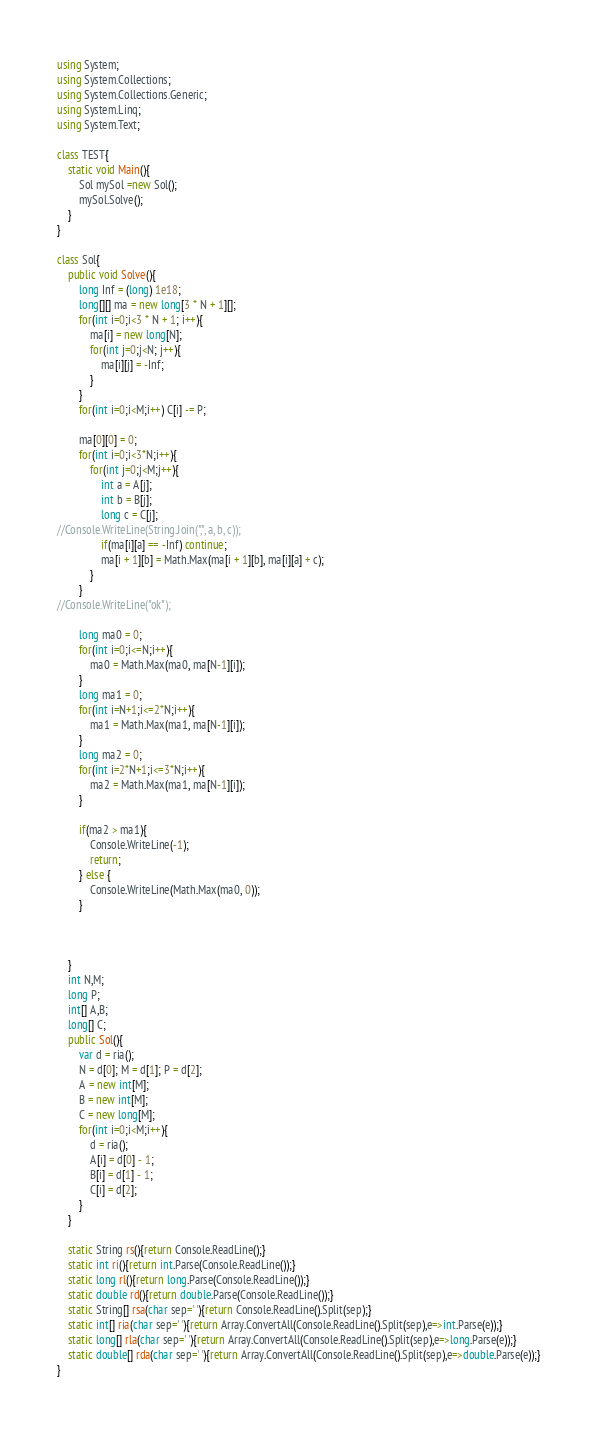Convert code to text. <code><loc_0><loc_0><loc_500><loc_500><_C#_>using System;
using System.Collections;
using System.Collections.Generic;
using System.Linq;
using System.Text;

class TEST{
	static void Main(){
		Sol mySol =new Sol();
		mySol.Solve();
	}
}

class Sol{
	public void Solve(){
		long Inf = (long) 1e18;
		long[][] ma = new long[3 * N + 1][];
		for(int i=0;i<3 * N + 1; i++){
			ma[i] = new long[N];
			for(int j=0;j<N; j++){
				ma[i][j] = -Inf;
			}
		}
		for(int i=0;i<M;i++) C[i] -= P;
		
		ma[0][0] = 0;
		for(int i=0;i<3*N;i++){
			for(int j=0;j<M;j++){
				int a = A[j];
				int b = B[j];
				long c = C[j];
//Console.WriteLine(String.Join(",", a, b, c));
				if(ma[i][a] == -Inf) continue;
				ma[i + 1][b] = Math.Max(ma[i + 1][b], ma[i][a] + c);
			}
		}
//Console.WriteLine("ok");
		
		long ma0 = 0;
		for(int i=0;i<=N;i++){
			ma0 = Math.Max(ma0, ma[N-1][i]);
		}
		long ma1 = 0;
		for(int i=N+1;i<=2*N;i++){
			ma1 = Math.Max(ma1, ma[N-1][i]);
		}
		long ma2 = 0;
		for(int i=2*N+1;i<=3*N;i++){
			ma2 = Math.Max(ma1, ma[N-1][i]);
		}
		
		if(ma2 > ma1){
			Console.WriteLine(-1);
			return;
		} else {
			Console.WriteLine(Math.Max(ma0, 0));
		}
		
		
		
	}
	int N,M;
	long P;
	int[] A,B;
	long[] C;
	public Sol(){
		var d = ria();
		N = d[0]; M = d[1]; P = d[2];
		A = new int[M];
		B = new int[M];
		C = new long[M];
		for(int i=0;i<M;i++){
			d = ria();
			A[i] = d[0] - 1;
			B[i] = d[1] - 1;
			C[i] = d[2];
		}
	}

	static String rs(){return Console.ReadLine();}
	static int ri(){return int.Parse(Console.ReadLine());}
	static long rl(){return long.Parse(Console.ReadLine());}
	static double rd(){return double.Parse(Console.ReadLine());}
	static String[] rsa(char sep=' '){return Console.ReadLine().Split(sep);}
	static int[] ria(char sep=' '){return Array.ConvertAll(Console.ReadLine().Split(sep),e=>int.Parse(e));}
	static long[] rla(char sep=' '){return Array.ConvertAll(Console.ReadLine().Split(sep),e=>long.Parse(e));}
	static double[] rda(char sep=' '){return Array.ConvertAll(Console.ReadLine().Split(sep),e=>double.Parse(e));}
}
</code> 